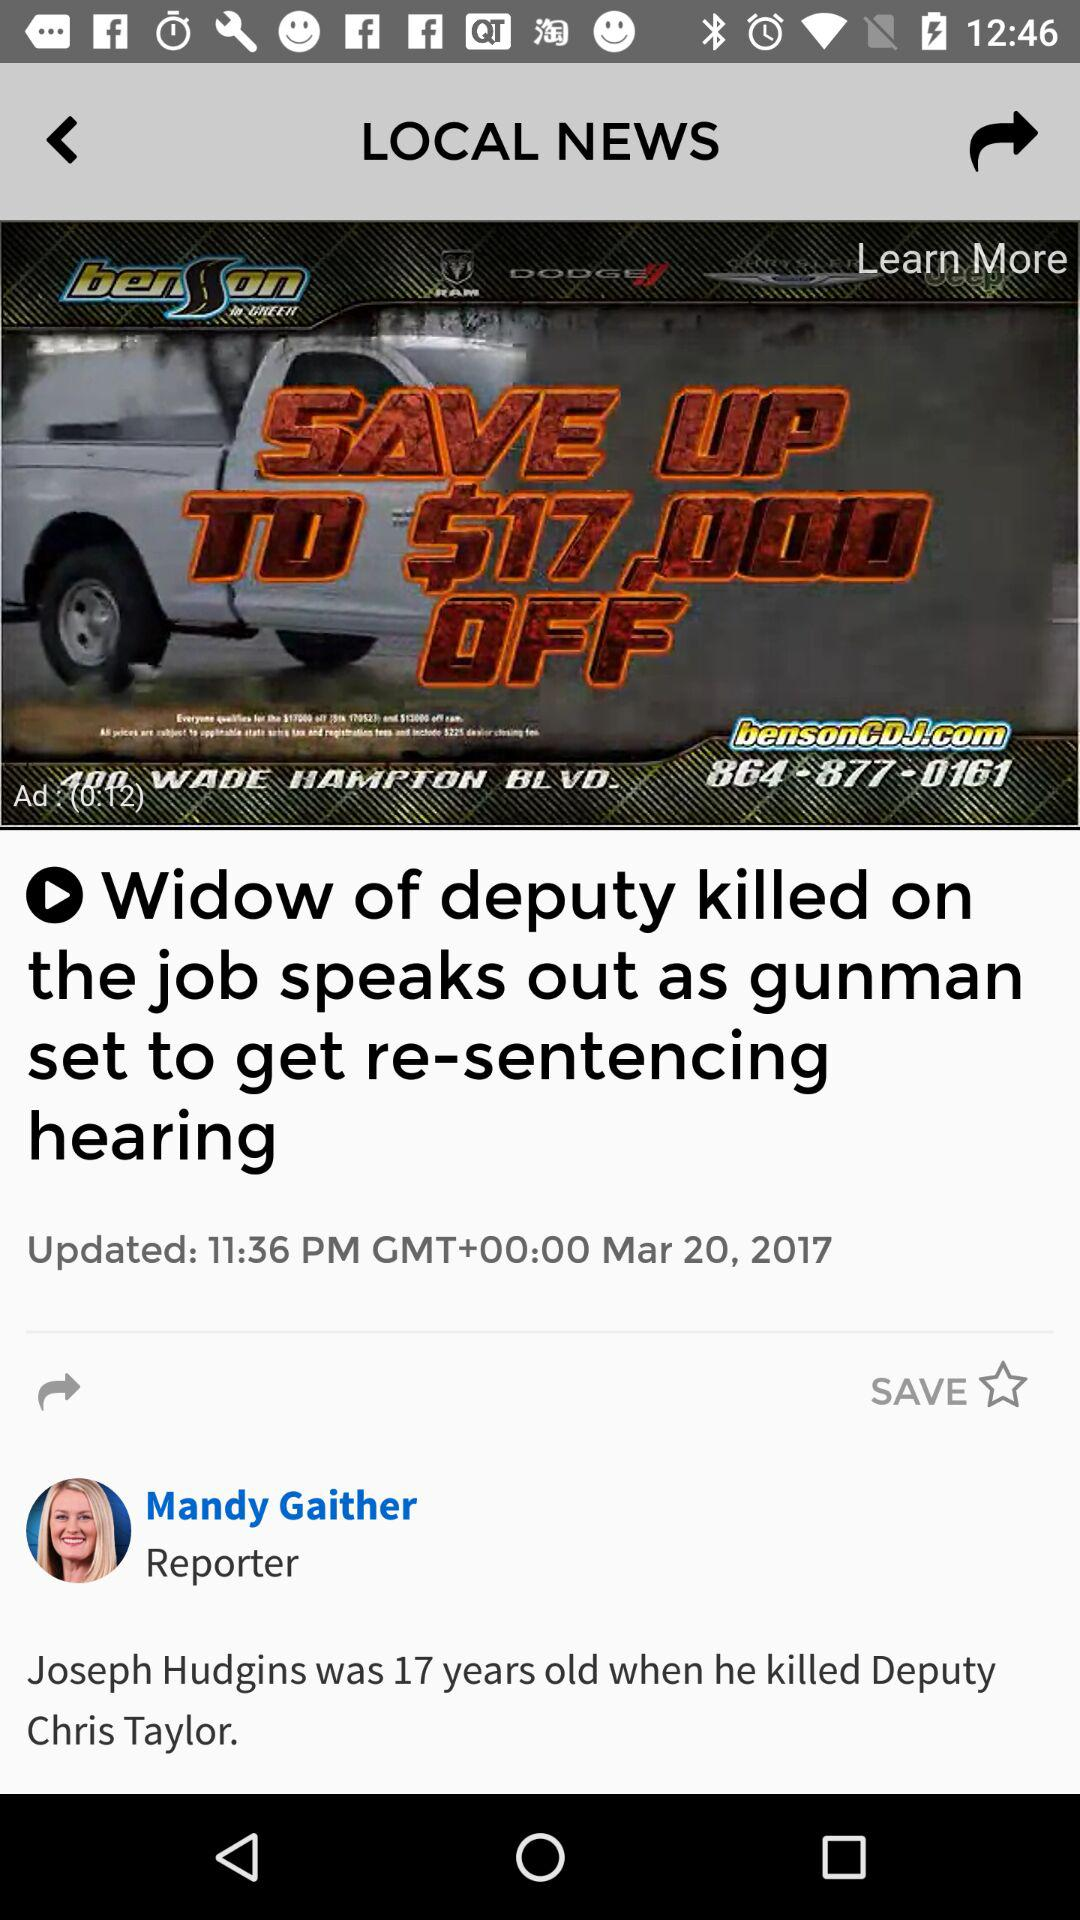What's the publication date of the article? The publication date is March 20, 2017. 